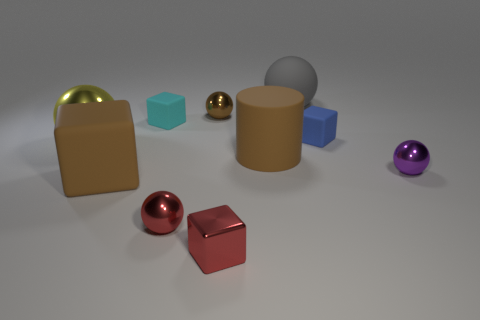Subtract all gray balls. How many balls are left? 4 Subtract all tiny brown metallic spheres. How many spheres are left? 4 Subtract all blue spheres. Subtract all red cylinders. How many spheres are left? 5 Subtract all cylinders. How many objects are left? 9 Add 7 red shiny things. How many red shiny things exist? 9 Subtract 0 yellow blocks. How many objects are left? 10 Subtract all small red blocks. Subtract all tiny rubber cubes. How many objects are left? 7 Add 3 cyan rubber cubes. How many cyan rubber cubes are left? 4 